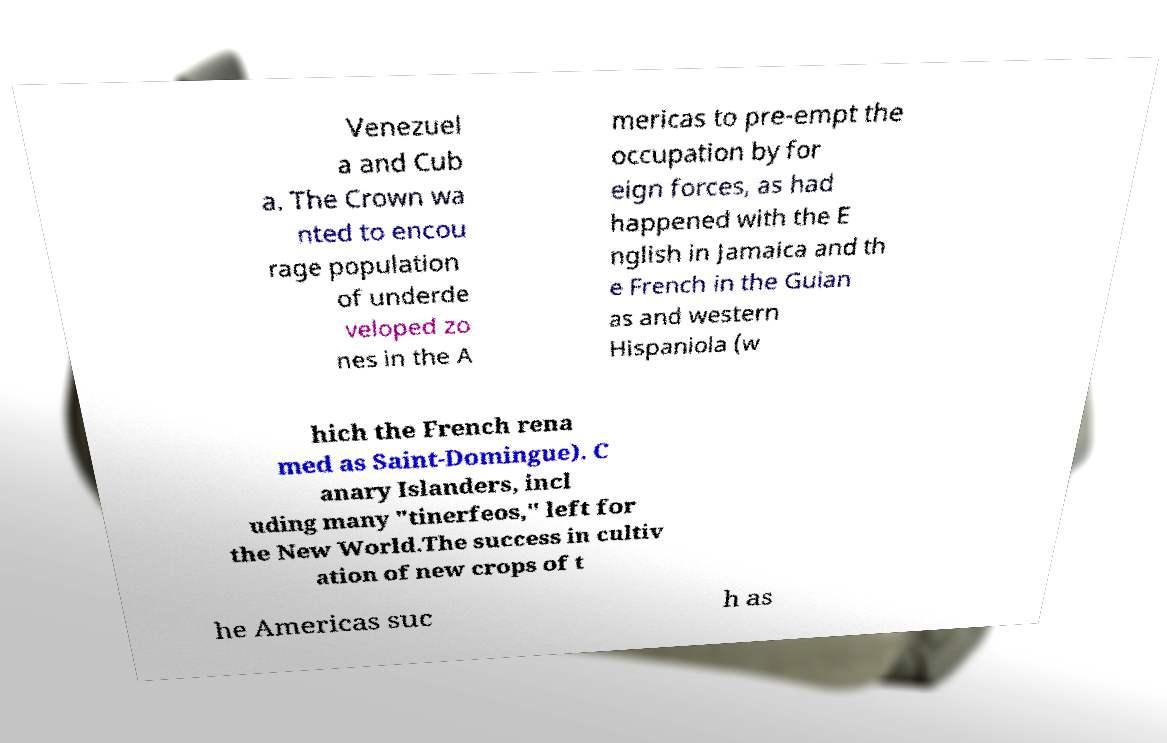I need the written content from this picture converted into text. Can you do that? Venezuel a and Cub a. The Crown wa nted to encou rage population of underde veloped zo nes in the A mericas to pre-empt the occupation by for eign forces, as had happened with the E nglish in Jamaica and th e French in the Guian as and western Hispaniola (w hich the French rena med as Saint-Domingue). C anary Islanders, incl uding many "tinerfeos," left for the New World.The success in cultiv ation of new crops of t he Americas suc h as 